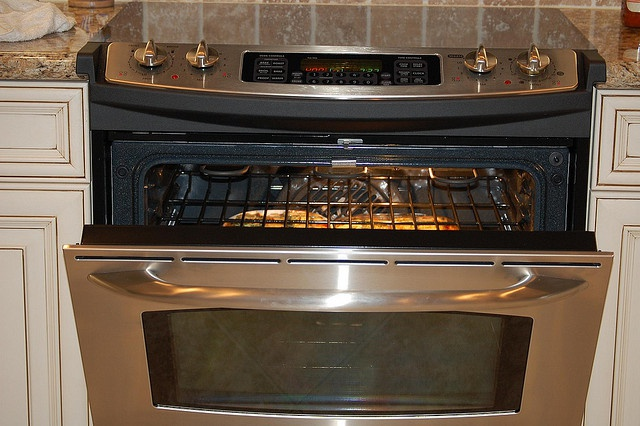Describe the objects in this image and their specific colors. I can see a oven in black, tan, maroon, and gray tones in this image. 